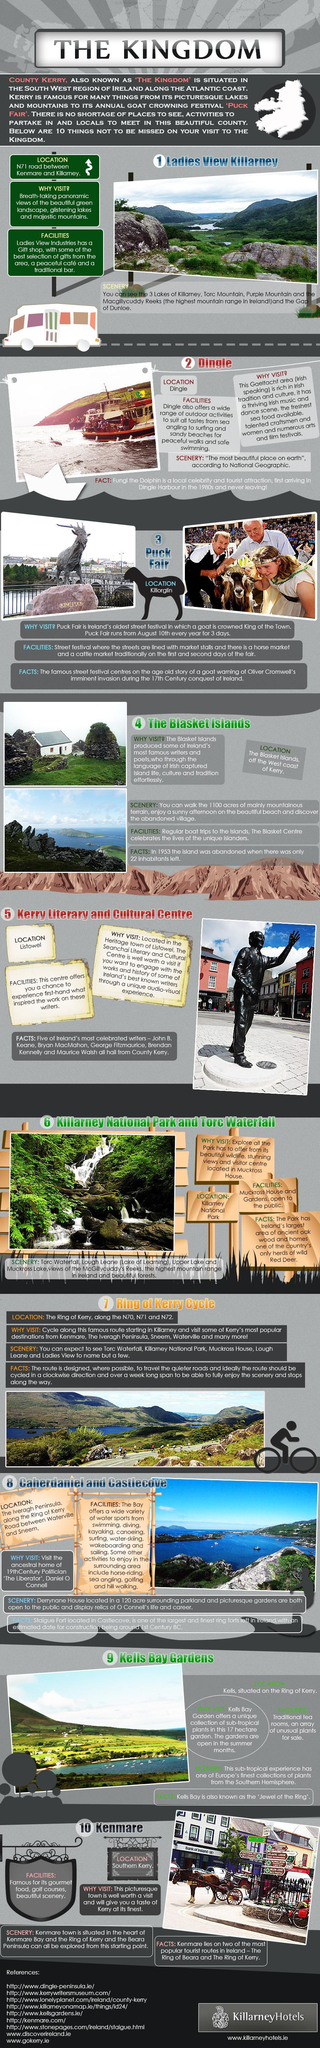Where is the Kerry Literary and Cultural Centre?
Answer the question with a short phrase. Listowel In which area is Dingle? Gaeltacht Who hasn't left Dingle Harbour since 80s? Fungi the Dolphin From where can you see the highest mountain range in Ireland? Ladies View Killarney Where is the Puck Fair held? Killorglin 